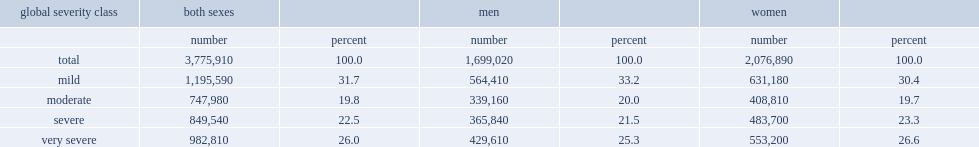How many canadians report a disability? 3775910.0. What is the percentage of both sexes classified as having a mild disability? 31.7. What is the percentage of both sexes classified as having a moderate disability? 19.8. What is the percentage of both sexes classified as having a severe disability? 22.5. What is the percentage of both sexes classified as having a very severe disability? 26.0. 